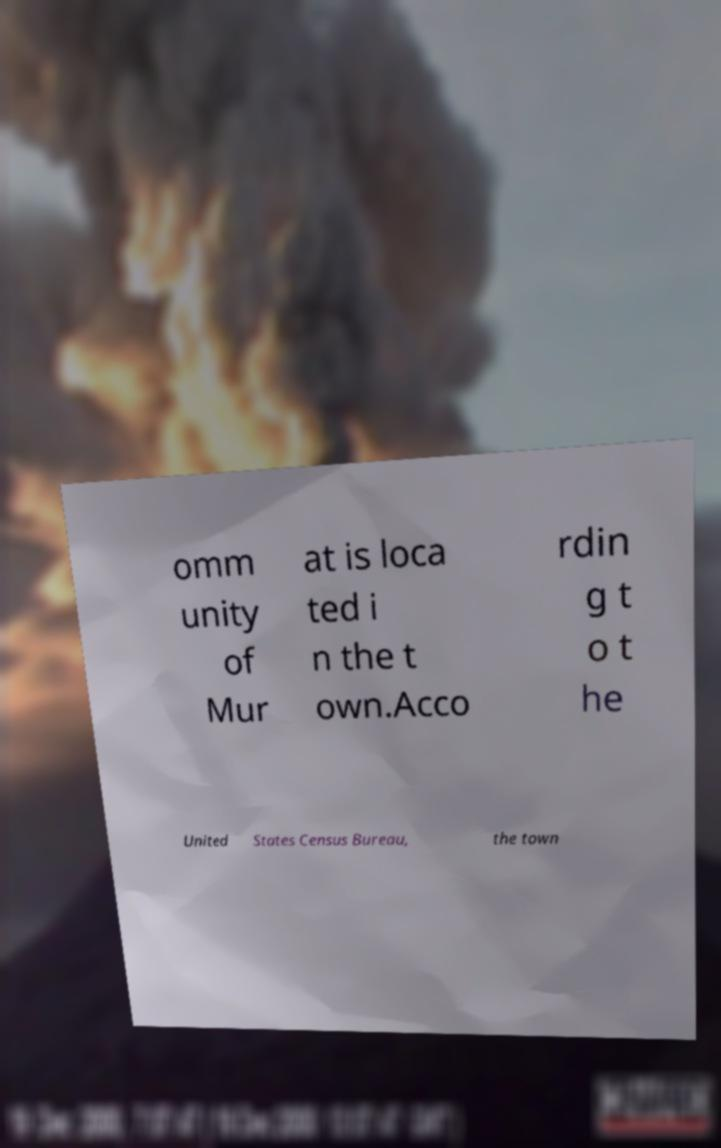Could you assist in decoding the text presented in this image and type it out clearly? omm unity of Mur at is loca ted i n the t own.Acco rdin g t o t he United States Census Bureau, the town 